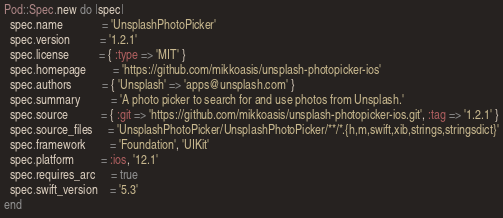Convert code to text. <code><loc_0><loc_0><loc_500><loc_500><_Ruby_>Pod::Spec.new do |spec|
  spec.name             = 'UnsplashPhotoPicker'
  spec.version          = '1.2.1'
  spec.license          = { :type => 'MIT' }
  spec.homepage         = 'https://github.com/mikkoasis/unsplash-photopicker-ios'
  spec.authors          = { 'Unsplash' => 'apps@unsplash.com' }
  spec.summary          = 'A photo picker to search for and use photos from Unsplash.'
  spec.source           = { :git => 'https://github.com/mikkoasis/unsplash-photopicker-ios.git', :tag => '1.2.1' }
  spec.source_files     = 'UnsplashPhotoPicker/UnsplashPhotoPicker/**/*.{h,m,swift,xib,strings,stringsdict}'
  spec.framework        = 'Foundation', 'UIKit'
  spec.platform         = :ios, '12.1'
  spec.requires_arc     = true
  spec.swift_version    = '5.3'
end
</code> 